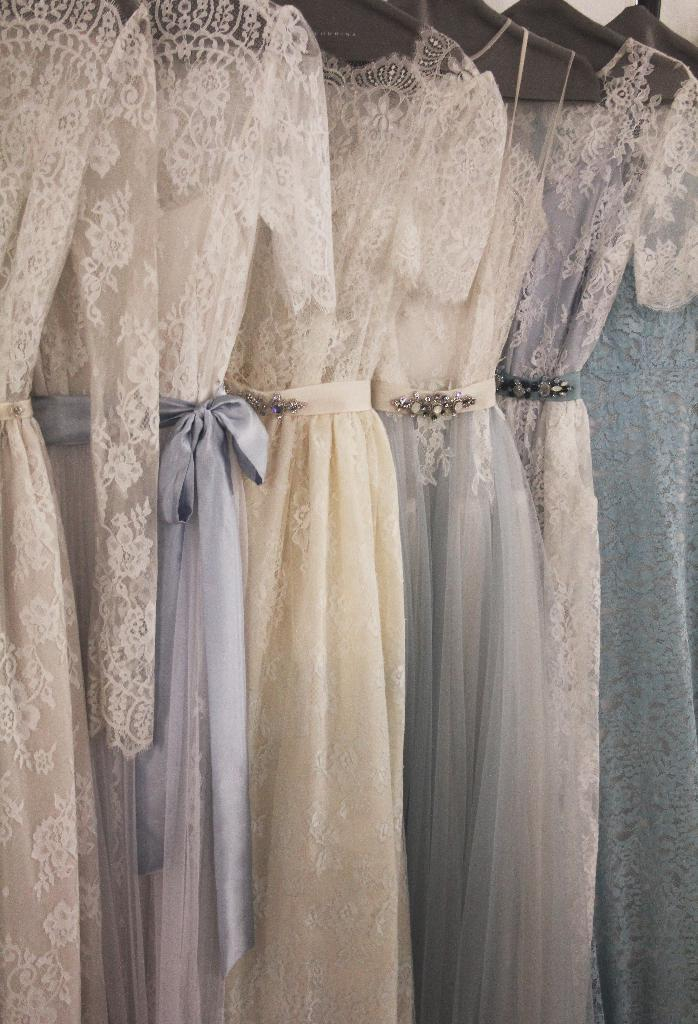What is hanging in the image? There are clothes hanging on a hanger in the image. What type of engine is powering the hat in the image? There is no hat or engine present in the image; it only features clothes hanging on a hanger. 